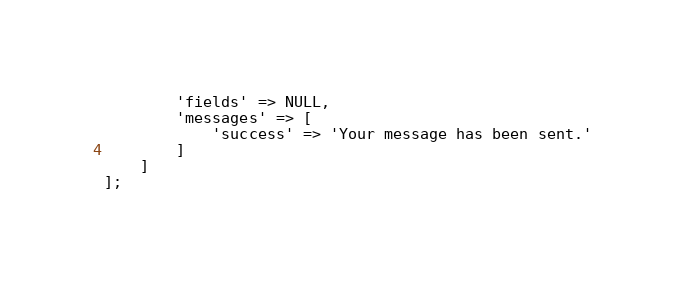Convert code to text. <code><loc_0><loc_0><loc_500><loc_500><_PHP_>        'fields' => NULL,
        'messages' => [
            'success' => 'Your message has been sent.'
        ]
    ]
];
</code> 